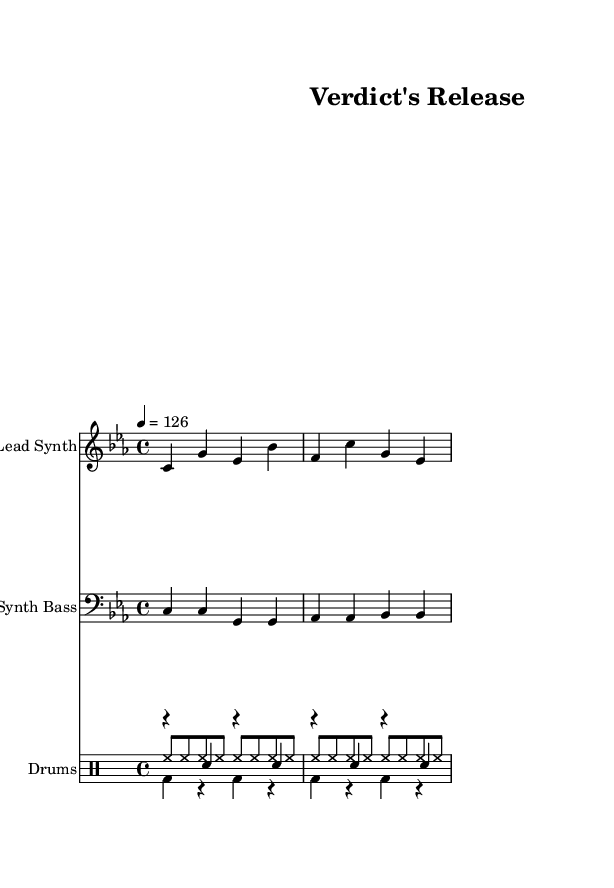What is the key signature of this music? The key signature is C minor, indicated by the presence of three flats in the key signature at the beginning of the piece.
Answer: C minor What is the time signature of this music? The time signature is presented at the beginning of the sheet music as 4/4, indicating four beats per measure, and each beat is a quarter note.
Answer: 4/4 What is the tempo marking of this music? The tempo marking shows "4 = 126," which means there are 126 quarter notes per minute, defining the speed of the music.
Answer: 126 How many measures are in the lead synth part? The lead synth part contains four measures, indicated by the vertical bar lines separating each group of notes.
Answer: 4 Which instrument plays the bass notes? The bass notes are played by the synth bass, labeled as such above the respective staff in the sheet music.
Answer: Synth Bass What rhythmic pattern is used in the drum kick part? The drum kick part consists of a simple two-beat pattern alternating with rests, indicated by the notation shown in the drum mode section.
Answer: BD r BD r What type of music is this piece categorized as? This piece is categorized as House music, as indicated by its driving rhythm, synthesizer elements, and repetitive structure typical of the genre.
Answer: House 